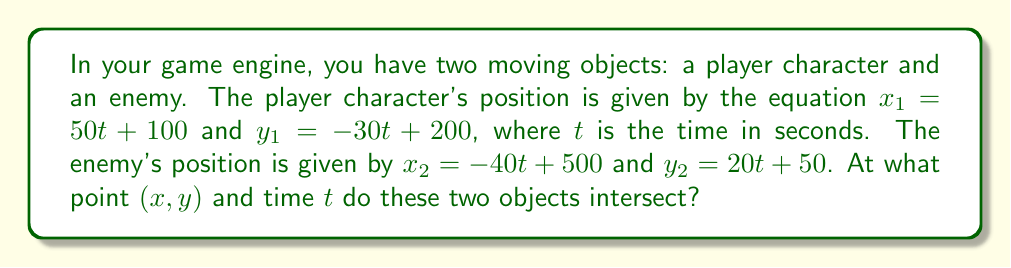Help me with this question. To solve this problem, we need to set up a system of equations and solve for the intersection point. Here's the step-by-step process:

1) We have two sets of equations:
   For the player: $x_1 = 50t + 100$, $y_1 = -30t + 200$
   For the enemy: $x_2 = -40t + 500$, $y_2 = 20t + 50$

2) At the intersection point, $x_1 = x_2$ and $y_1 = y_2$. So we can set up two equations:

   $50t + 100 = -40t + 500$
   $-30t + 200 = 20t + 50$

3) Let's solve the first equation:
   $50t + 100 = -40t + 500$
   $90t = 400$
   $t = \frac{400}{90} = \frac{40}{9} \approx 4.44$ seconds

4) Now let's verify this $t$ value in the second equation:
   $-30(\frac{40}{9}) + 200 = 20(\frac{40}{9}) + 50$
   $-\frac{1200}{9} + 200 = \frac{800}{9} + 50$
   $\frac{600}{9} = \frac{800}{9} + 50$
   $\frac{600}{9} = \frac{1250}{9}$

   This is indeed true, confirming our solution for $t$.

5) Now that we know $t$, we can find $x$ and $y$ by plugging $t$ back into either set of equations. Let's use the player's equations:

   $x = 50(\frac{40}{9}) + 100 = \frac{2000}{9} + 100 = \frac{2900}{9} \approx 322.22$
   $y = -30(\frac{40}{9}) + 200 = -\frac{1200}{9} + 200 = \frac{600}{9} \approx 66.67$

Therefore, the intersection point is $(\frac{2900}{9}, \frac{600}{9})$ or approximately $(322.22, 66.67)$ at time $t = \frac{40}{9} \approx 4.44$ seconds.
Answer: The objects intersect at the point $(\frac{2900}{9}, \frac{600}{9})$ or approximately $(322.22, 66.67)$ at time $t = \frac{40}{9} \approx 4.44$ seconds. 